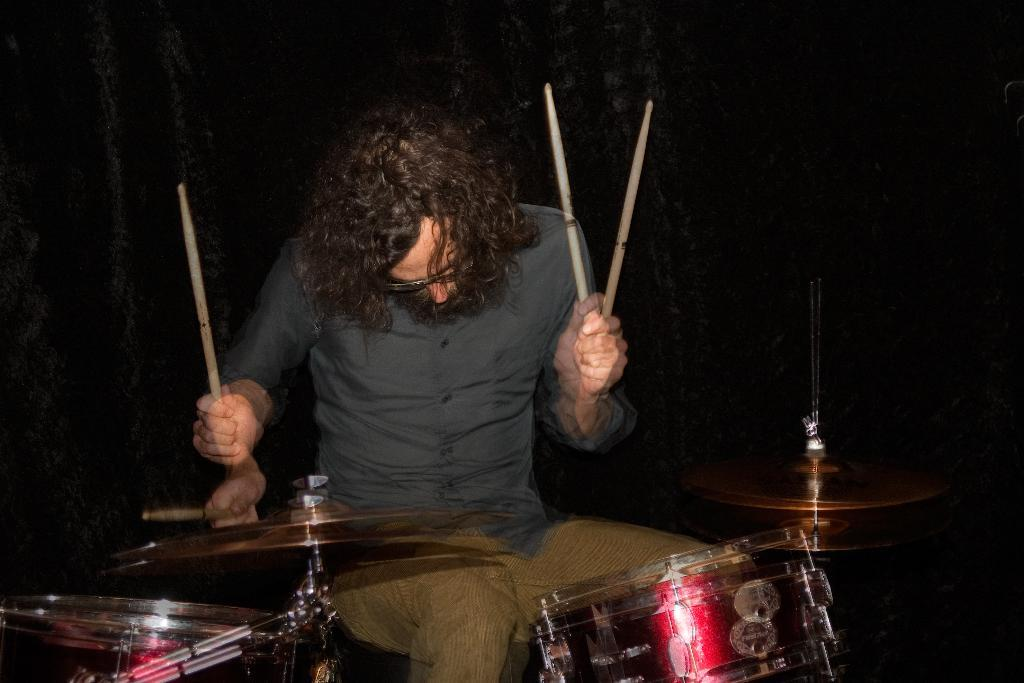What is the man in the image doing? The man is playing the drums. What is the man using to play the drums? The man is using sticks to play the drums. Can you see a basketball being used by the man in the image? No, there is no basketball present in the image. The man is playing the drums with drumsticks, not a basketball. 